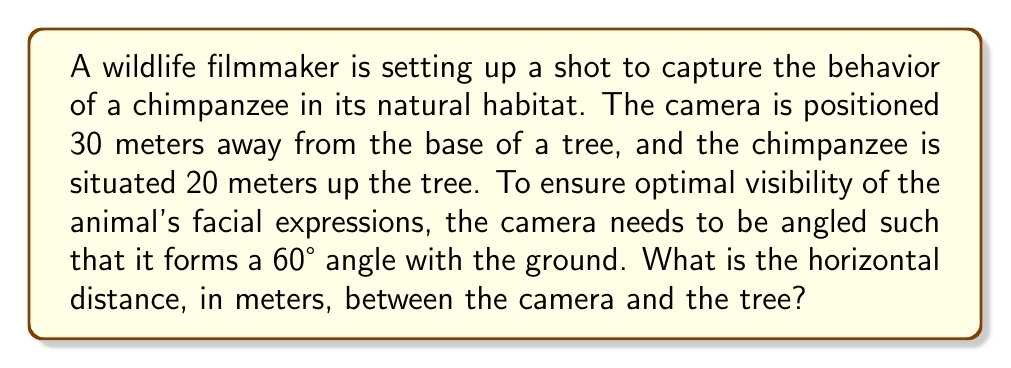Help me with this question. Let's approach this step-by-step:

1) We can visualize this scenario as a right-angled triangle, where:
   - The camera-to-tree base distance is the base of the triangle
   - The height of the chimpanzee in the tree is the height of the triangle
   - The line of sight from the camera to the chimpanzee is the hypotenuse

2) We know that the angle between the ground and the camera's line of sight is 60°.

3) In a right-angled triangle, we can use trigonometric ratios. Here, we'll use the tangent ratio:

   $$\tan \theta = \frac{\text{opposite}}{\text{adjacent}}$$

4) In our case:
   $$\tan 60° = \frac{20}{\text{horizontal distance}}$$

5) We know that $\tan 60° = \sqrt{3}$, so we can write:

   $$\sqrt{3} = \frac{20}{\text{horizontal distance}}$$

6) Cross-multiplying:

   $$\sqrt{3} \cdot \text{horizontal distance} = 20$$

7) Solving for the horizontal distance:

   $$\text{horizontal distance} = \frac{20}{\sqrt{3}} = \frac{20\sqrt{3}}{3} \approx 11.55$$

Therefore, the horizontal distance between the camera and the tree is approximately 11.55 meters.

[asy]
import geometry;

size(200);

pair A = (0,0);
pair B = (11.55,0);
pair C = (11.55,20);

draw(A--B--C--A);

label("30m", (5.775,-2), S);
label("20m", (13.55,10), E);
label("Camera", (-2,0), W);
label("Tree", (13.55,0), E);
label("Chimpanzee", (13.55,22), E);

draw(arc(B,1,0,60), Arrow);
label("60°", (12.35,1.2), NE);
</asy]
Answer: $$\frac{20\sqrt{3}}{3} \approx 11.55 \text{ meters}$$ 